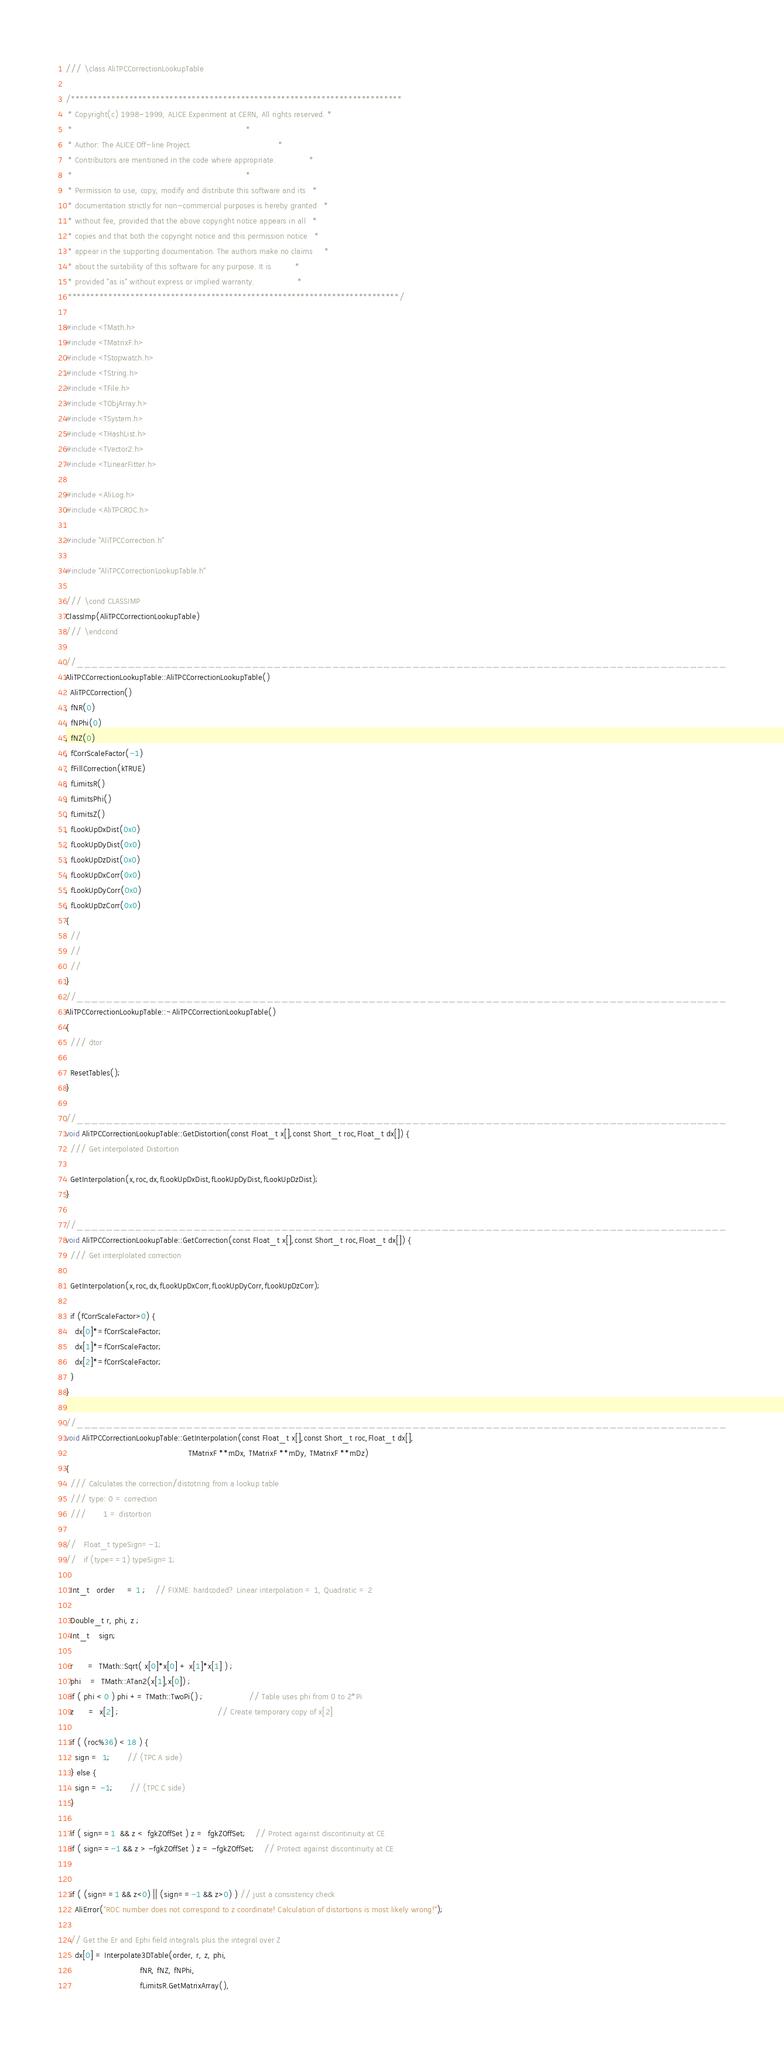<code> <loc_0><loc_0><loc_500><loc_500><_C++_>/// \class AliTPCCorrectionLookupTable

/**************************************************************************
 * Copyright(c) 1998-1999, ALICE Experiment at CERN, All rights reserved. *
 *                                                                        *
 * Author: The ALICE Off-line Project.                                    *
 * Contributors are mentioned in the code where appropriate.              *
 *                                                                        *
 * Permission to use, copy, modify and distribute this software and its   *
 * documentation strictly for non-commercial purposes is hereby granted   *
 * without fee, provided that the above copyright notice appears in all   *
 * copies and that both the copyright notice and this permission notice   *
 * appear in the supporting documentation. The authors make no claims     *
 * about the suitability of this software for any purpose. It is          *
 * provided "as is" without express or implied warranty.                  *
 **************************************************************************/

#include <TMath.h>
#include <TMatrixF.h>
#include <TStopwatch.h>
#include <TString.h>
#include <TFile.h>
#include <TObjArray.h>
#include <TSystem.h>
#include <THashList.h>
#include <TVector2.h>
#include <TLinearFitter.h>

#include <AliLog.h>
#include <AliTPCROC.h>

#include "AliTPCCorrection.h"

#include "AliTPCCorrectionLookupTable.h"

/// \cond CLASSIMP
ClassImp(AliTPCCorrectionLookupTable)
/// \endcond

//_________________________________________________________________________________________
AliTPCCorrectionLookupTable::AliTPCCorrectionLookupTable()
: AliTPCCorrection()
, fNR(0)
, fNPhi(0)
, fNZ(0)
, fCorrScaleFactor(-1)
, fFillCorrection(kTRUE)
, fLimitsR()
, fLimitsPhi()
, fLimitsZ()
, fLookUpDxDist(0x0)
, fLookUpDyDist(0x0)
, fLookUpDzDist(0x0)
, fLookUpDxCorr(0x0)
, fLookUpDyCorr(0x0)
, fLookUpDzCorr(0x0)
{
  //
  //
  //
}
//_________________________________________________________________________________________
AliTPCCorrectionLookupTable::~AliTPCCorrectionLookupTable()
{
  /// dtor

  ResetTables();
}

//_________________________________________________________________________________________
void AliTPCCorrectionLookupTable::GetDistortion(const Float_t x[],const Short_t roc,Float_t dx[]) {
  /// Get interpolated Distortion

  GetInterpolation(x,roc,dx,fLookUpDxDist,fLookUpDyDist,fLookUpDzDist);
}

//_________________________________________________________________________________________
void AliTPCCorrectionLookupTable::GetCorrection(const Float_t x[],const Short_t roc,Float_t dx[]) {
  /// Get interplolated correction

  GetInterpolation(x,roc,dx,fLookUpDxCorr,fLookUpDyCorr,fLookUpDzCorr);

  if (fCorrScaleFactor>0) {
    dx[0]*=fCorrScaleFactor;
    dx[1]*=fCorrScaleFactor;
    dx[2]*=fCorrScaleFactor;
  }
}

//_________________________________________________________________________________________
void AliTPCCorrectionLookupTable::GetInterpolation(const Float_t x[],const Short_t roc,Float_t dx[],
                                                   TMatrixF **mDx, TMatrixF **mDy, TMatrixF **mDz)
{
  /// Calculates the correction/distotring from a lookup table
  /// type: 0 = correction
  ///       1 = distortion

//   Float_t typeSign=-1;
//   if (type==1) typeSign=1;

  Int_t   order     = 1 ;    // FIXME: hardcoded? Linear interpolation = 1, Quadratic = 2

  Double_t r, phi, z ;
  Int_t    sign;

  r      =  TMath::Sqrt( x[0]*x[0] + x[1]*x[1] ) ;
  phi    =  TMath::ATan2(x[1],x[0]) ;
  if ( phi < 0 ) phi += TMath::TwoPi() ;                   // Table uses phi from 0 to 2*Pi
  z      =  x[2] ;                                         // Create temporary copy of x[2]

  if ( (roc%36) < 18 ) {
    sign =  1;       // (TPC A side)
  } else {
    sign = -1;       // (TPC C side)
  }

  if ( sign==1  && z <  fgkZOffSet ) z =  fgkZOffSet;    // Protect against discontinuity at CE
  if ( sign==-1 && z > -fgkZOffSet ) z = -fgkZOffSet;    // Protect against discontinuity at CE


  if ( (sign==1 && z<0) || (sign==-1 && z>0) ) // just a consistency check
    AliError("ROC number does not correspond to z coordinate! Calculation of distortions is most likely wrong!");

  // Get the Er and Ephi field integrals plus the integral over Z
    dx[0] = Interpolate3DTable(order, r, z, phi,
                               fNR, fNZ, fNPhi,
                               fLimitsR.GetMatrixArray(),</code> 